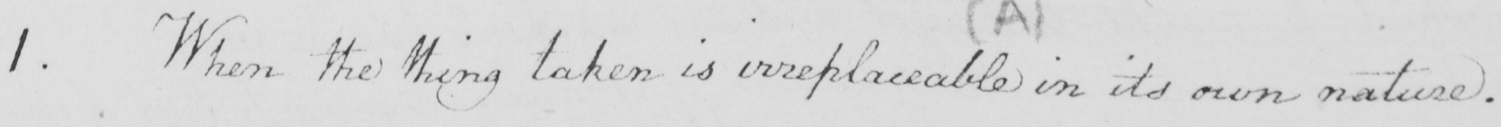Can you read and transcribe this handwriting? 1 . When the thing taken is irreplaceable in its own nature . 